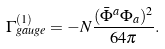<formula> <loc_0><loc_0><loc_500><loc_500>\Gamma ^ { ( 1 ) } _ { g a u g e } = - N \frac { ( \bar { \Phi } ^ { a } \Phi _ { a } ) ^ { 2 } } { 6 4 \pi } .</formula> 